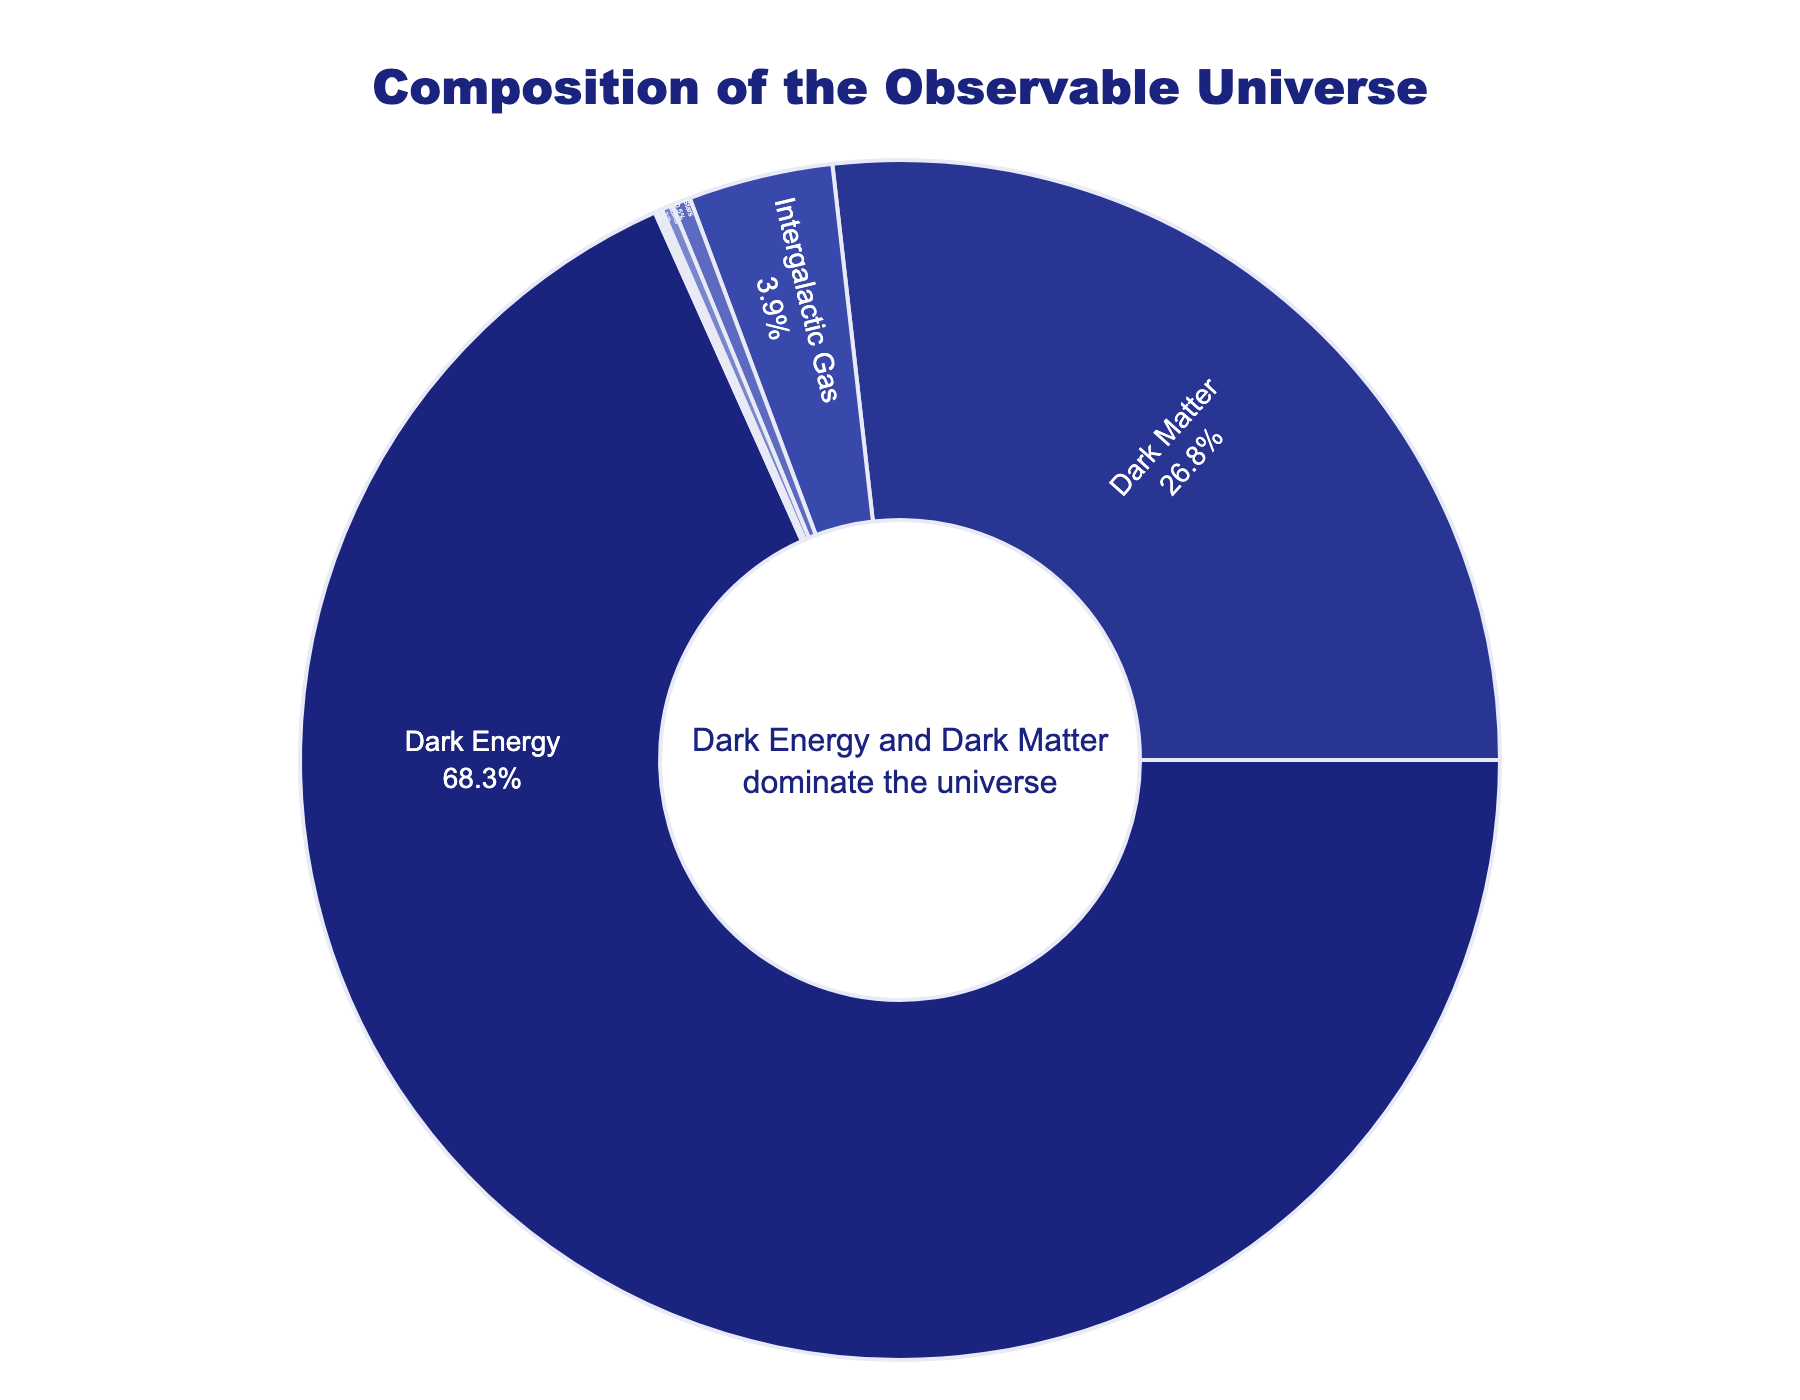What component makes up the largest percentage of the observable universe? The figure shows that Dark Energy occupies the largest segment in the pie chart and its label indicates it makes up 68.3% of the observable universe.
Answer: Dark Energy How much larger is the percentage of Dark Matter than that of Stars? Dark Matter constitutes 26.8% of the observable universe, while Stars make up 0.5%. Subtracting these values gives 26.8 - 0.5 = 26.3%.
Answer: 26.3% Which two components together constitute less than 1% of the observable universe? The pie chart indicates that Neutrinos and Heavy Elements each make up 0.3% and 0.1% respectively. Summing these values yields 0.3 + 0.1 = 0.4%, which is less than 1%.
Answer: Neutrinos and Heavy Elements Is the percentage of Intergalactic Gas greater than the sum of percentages of Stars and Black Holes? Intergalactic Gas constitutes 3.9% of the observable universe. Stars and Black Holes together make up 0.5% + 0.1% = 0.6%. Since 3.9% is greater than 0.6%, the answer is yes.
Answer: Yes What is the color associated with Dark Matter in the pie chart? Observing the color attributed to Dark Matter indicates it is the second darkest shade of blue in the palette used.
Answer: Dark blue If you sum the percentages of all components except Dark Energy and Dark Matter, what is the total percentage? Adding the percentages of Intergalactic Gas (3.9%), Stars (0.5%), Neutrinos (0.3%), Heavy Elements (0.1%), and Black Holes (0.1%) yields 3.9 + 0.5 + 0.3 + 0.1 + 0.1 = 4.9%.
Answer: 4.9% What percentage of the observable universe is constituted by components other than Dark Energy? Dark Energy makes up 68.3%. Subtracting this from 100% yields 100 - 68.3 = 31.7%.
Answer: 31.7% What annotation is included within the figure? The pie chart includes an annotation in the center that states "Dark Energy and Dark Matter dominate the universe."
Answer: Dark Energy and Dark Matter dominate the universe 